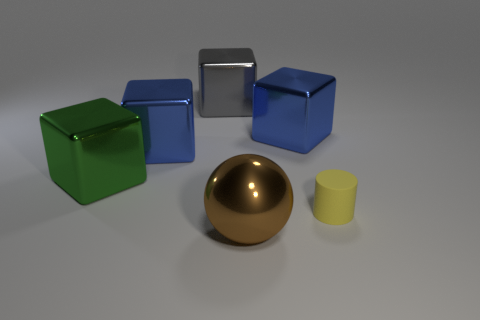Subtract all purple blocks. Subtract all green cylinders. How many blocks are left? 4 Add 1 tiny cylinders. How many objects exist? 7 Subtract all cubes. How many objects are left? 2 Subtract 0 gray cylinders. How many objects are left? 6 Subtract all blue things. Subtract all large green objects. How many objects are left? 3 Add 6 large green things. How many large green things are left? 7 Add 1 big blue shiny things. How many big blue shiny things exist? 3 